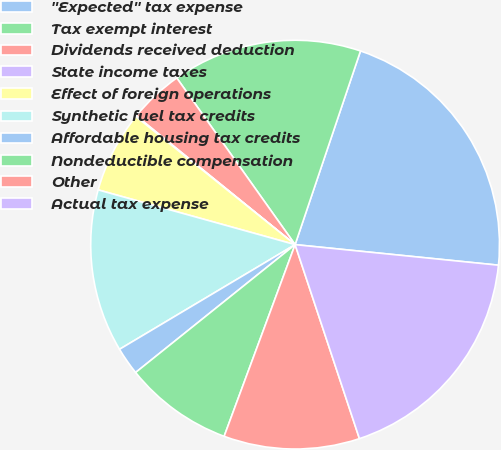<chart> <loc_0><loc_0><loc_500><loc_500><pie_chart><fcel>''Expected'' tax expense<fcel>Tax exempt interest<fcel>Dividends received deduction<fcel>State income taxes<fcel>Effect of foreign operations<fcel>Synthetic fuel tax credits<fcel>Affordable housing tax credits<fcel>Nondeductible compensation<fcel>Other<fcel>Actual tax expense<nl><fcel>21.42%<fcel>15.01%<fcel>4.33%<fcel>0.06%<fcel>6.47%<fcel>12.87%<fcel>2.2%<fcel>8.6%<fcel>10.74%<fcel>18.3%<nl></chart> 